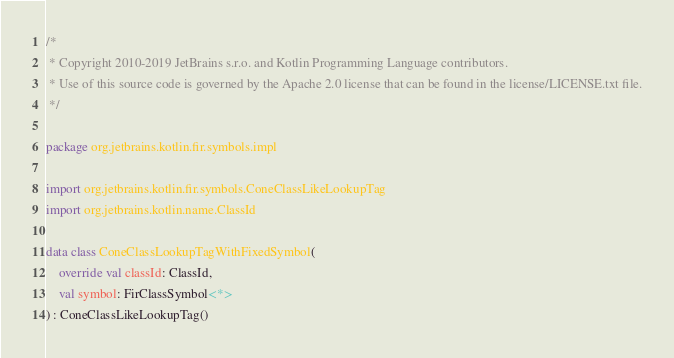<code> <loc_0><loc_0><loc_500><loc_500><_Kotlin_>/*
 * Copyright 2010-2019 JetBrains s.r.o. and Kotlin Programming Language contributors.
 * Use of this source code is governed by the Apache 2.0 license that can be found in the license/LICENSE.txt file.
 */

package org.jetbrains.kotlin.fir.symbols.impl

import org.jetbrains.kotlin.fir.symbols.ConeClassLikeLookupTag
import org.jetbrains.kotlin.name.ClassId

data class ConeClassLookupTagWithFixedSymbol(
    override val classId: ClassId,
    val symbol: FirClassSymbol<*>
) : ConeClassLikeLookupTag()</code> 